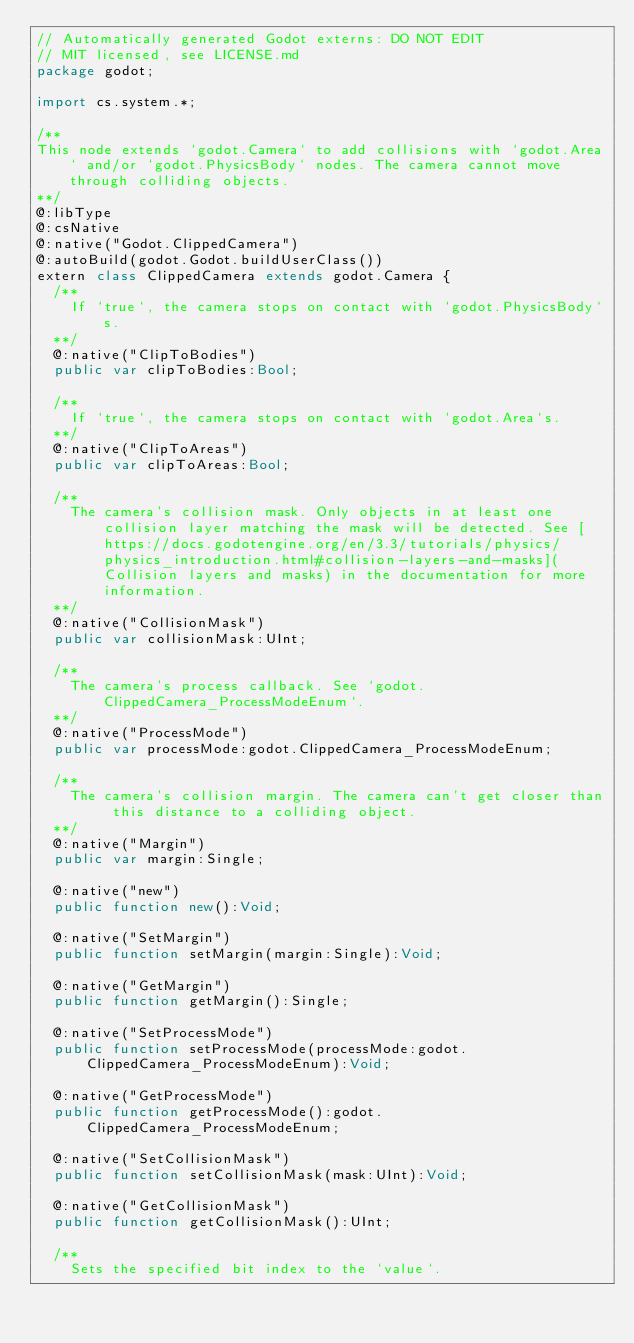<code> <loc_0><loc_0><loc_500><loc_500><_Haxe_>// Automatically generated Godot externs: DO NOT EDIT
// MIT licensed, see LICENSE.md
package godot;

import cs.system.*;

/**
This node extends `godot.Camera` to add collisions with `godot.Area` and/or `godot.PhysicsBody` nodes. The camera cannot move through colliding objects.
**/
@:libType
@:csNative
@:native("Godot.ClippedCamera")
@:autoBuild(godot.Godot.buildUserClass())
extern class ClippedCamera extends godot.Camera {
	/**		
		If `true`, the camera stops on contact with `godot.PhysicsBody`s.
	**/
	@:native("ClipToBodies")
	public var clipToBodies:Bool;

	/**		
		If `true`, the camera stops on contact with `godot.Area`s.
	**/
	@:native("ClipToAreas")
	public var clipToAreas:Bool;

	/**		
		The camera's collision mask. Only objects in at least one collision layer matching the mask will be detected. See [https://docs.godotengine.org/en/3.3/tutorials/physics/physics_introduction.html#collision-layers-and-masks](Collision layers and masks) in the documentation for more information.
	**/
	@:native("CollisionMask")
	public var collisionMask:UInt;

	/**		
		The camera's process callback. See `godot.ClippedCamera_ProcessModeEnum`.
	**/
	@:native("ProcessMode")
	public var processMode:godot.ClippedCamera_ProcessModeEnum;

	/**		
		The camera's collision margin. The camera can't get closer than this distance to a colliding object.
	**/
	@:native("Margin")
	public var margin:Single;

	@:native("new")
	public function new():Void;

	@:native("SetMargin")
	public function setMargin(margin:Single):Void;

	@:native("GetMargin")
	public function getMargin():Single;

	@:native("SetProcessMode")
	public function setProcessMode(processMode:godot.ClippedCamera_ProcessModeEnum):Void;

	@:native("GetProcessMode")
	public function getProcessMode():godot.ClippedCamera_ProcessModeEnum;

	@:native("SetCollisionMask")
	public function setCollisionMask(mask:UInt):Void;

	@:native("GetCollisionMask")
	public function getCollisionMask():UInt;

	/**		
		Sets the specified bit index to the `value`.
		</code> 